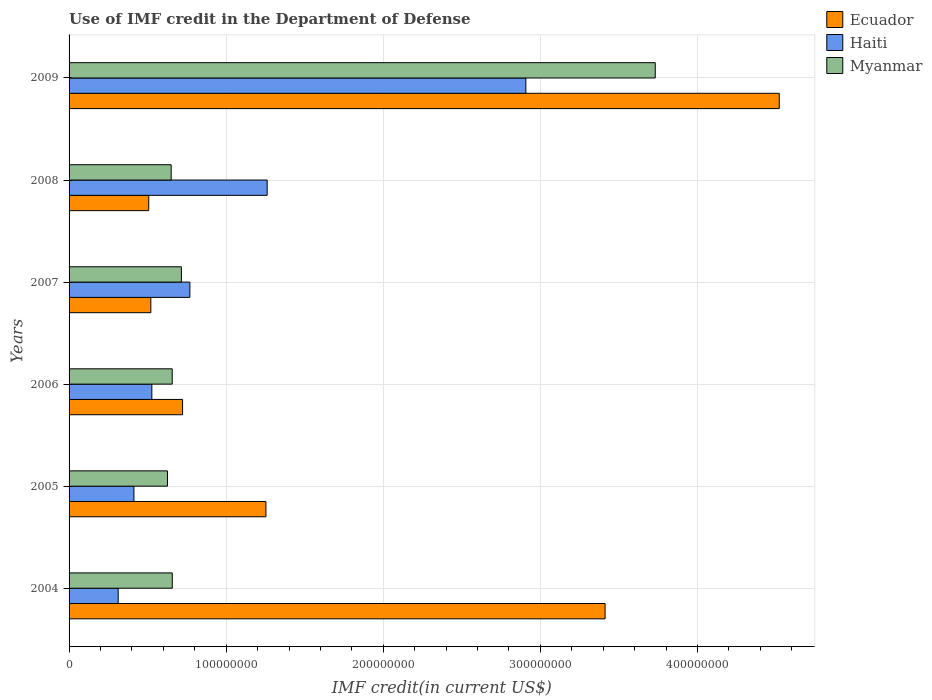How many different coloured bars are there?
Provide a succinct answer. 3. Are the number of bars per tick equal to the number of legend labels?
Offer a terse response. Yes. Are the number of bars on each tick of the Y-axis equal?
Your answer should be very brief. Yes. How many bars are there on the 4th tick from the top?
Your answer should be very brief. 3. How many bars are there on the 5th tick from the bottom?
Provide a succinct answer. 3. What is the IMF credit in the Department of Defense in Myanmar in 2005?
Keep it short and to the point. 6.26e+07. Across all years, what is the maximum IMF credit in the Department of Defense in Ecuador?
Your answer should be compact. 4.52e+08. Across all years, what is the minimum IMF credit in the Department of Defense in Haiti?
Provide a succinct answer. 3.13e+07. In which year was the IMF credit in the Department of Defense in Haiti maximum?
Give a very brief answer. 2009. What is the total IMF credit in the Department of Defense in Ecuador in the graph?
Ensure brevity in your answer.  1.09e+09. What is the difference between the IMF credit in the Department of Defense in Haiti in 2005 and that in 2008?
Offer a terse response. -8.48e+07. What is the difference between the IMF credit in the Department of Defense in Myanmar in 2004 and the IMF credit in the Department of Defense in Haiti in 2005?
Offer a very short reply. 2.44e+07. What is the average IMF credit in the Department of Defense in Ecuador per year?
Your answer should be very brief. 1.82e+08. In the year 2007, what is the difference between the IMF credit in the Department of Defense in Ecuador and IMF credit in the Department of Defense in Myanmar?
Give a very brief answer. -1.95e+07. In how many years, is the IMF credit in the Department of Defense in Myanmar greater than 260000000 US$?
Provide a succinct answer. 1. What is the ratio of the IMF credit in the Department of Defense in Ecuador in 2004 to that in 2007?
Offer a terse response. 6.56. Is the IMF credit in the Department of Defense in Ecuador in 2008 less than that in 2009?
Provide a succinct answer. Yes. Is the difference between the IMF credit in the Department of Defense in Ecuador in 2005 and 2008 greater than the difference between the IMF credit in the Department of Defense in Myanmar in 2005 and 2008?
Provide a succinct answer. Yes. What is the difference between the highest and the second highest IMF credit in the Department of Defense in Myanmar?
Your answer should be very brief. 3.02e+08. What is the difference between the highest and the lowest IMF credit in the Department of Defense in Ecuador?
Offer a terse response. 4.01e+08. What does the 3rd bar from the top in 2004 represents?
Make the answer very short. Ecuador. What does the 1st bar from the bottom in 2006 represents?
Ensure brevity in your answer.  Ecuador. Does the graph contain any zero values?
Offer a very short reply. No. Does the graph contain grids?
Your response must be concise. Yes. Where does the legend appear in the graph?
Offer a very short reply. Top right. How many legend labels are there?
Your answer should be compact. 3. How are the legend labels stacked?
Ensure brevity in your answer.  Vertical. What is the title of the graph?
Provide a short and direct response. Use of IMF credit in the Department of Defense. Does "Algeria" appear as one of the legend labels in the graph?
Keep it short and to the point. No. What is the label or title of the X-axis?
Ensure brevity in your answer.  IMF credit(in current US$). What is the label or title of the Y-axis?
Make the answer very short. Years. What is the IMF credit(in current US$) of Ecuador in 2004?
Give a very brief answer. 3.41e+08. What is the IMF credit(in current US$) in Haiti in 2004?
Provide a short and direct response. 3.13e+07. What is the IMF credit(in current US$) of Myanmar in 2004?
Offer a very short reply. 6.57e+07. What is the IMF credit(in current US$) of Ecuador in 2005?
Offer a very short reply. 1.25e+08. What is the IMF credit(in current US$) in Haiti in 2005?
Keep it short and to the point. 4.13e+07. What is the IMF credit(in current US$) in Myanmar in 2005?
Provide a succinct answer. 6.26e+07. What is the IMF credit(in current US$) in Ecuador in 2006?
Your response must be concise. 7.23e+07. What is the IMF credit(in current US$) in Haiti in 2006?
Your response must be concise. 5.27e+07. What is the IMF credit(in current US$) in Myanmar in 2006?
Your answer should be compact. 6.57e+07. What is the IMF credit(in current US$) of Ecuador in 2007?
Offer a terse response. 5.20e+07. What is the IMF credit(in current US$) in Haiti in 2007?
Offer a very short reply. 7.69e+07. What is the IMF credit(in current US$) in Myanmar in 2007?
Offer a terse response. 7.15e+07. What is the IMF credit(in current US$) in Ecuador in 2008?
Keep it short and to the point. 5.07e+07. What is the IMF credit(in current US$) in Haiti in 2008?
Provide a succinct answer. 1.26e+08. What is the IMF credit(in current US$) of Myanmar in 2008?
Your answer should be compact. 6.50e+07. What is the IMF credit(in current US$) of Ecuador in 2009?
Offer a very short reply. 4.52e+08. What is the IMF credit(in current US$) of Haiti in 2009?
Provide a short and direct response. 2.91e+08. What is the IMF credit(in current US$) of Myanmar in 2009?
Your answer should be very brief. 3.73e+08. Across all years, what is the maximum IMF credit(in current US$) in Ecuador?
Give a very brief answer. 4.52e+08. Across all years, what is the maximum IMF credit(in current US$) of Haiti?
Ensure brevity in your answer.  2.91e+08. Across all years, what is the maximum IMF credit(in current US$) of Myanmar?
Your answer should be compact. 3.73e+08. Across all years, what is the minimum IMF credit(in current US$) of Ecuador?
Ensure brevity in your answer.  5.07e+07. Across all years, what is the minimum IMF credit(in current US$) of Haiti?
Your response must be concise. 3.13e+07. Across all years, what is the minimum IMF credit(in current US$) in Myanmar?
Your response must be concise. 6.26e+07. What is the total IMF credit(in current US$) in Ecuador in the graph?
Provide a succinct answer. 1.09e+09. What is the total IMF credit(in current US$) in Haiti in the graph?
Make the answer very short. 6.19e+08. What is the total IMF credit(in current US$) of Myanmar in the graph?
Provide a short and direct response. 7.04e+08. What is the difference between the IMF credit(in current US$) of Ecuador in 2004 and that in 2005?
Provide a succinct answer. 2.16e+08. What is the difference between the IMF credit(in current US$) in Haiti in 2004 and that in 2005?
Give a very brief answer. -1.00e+07. What is the difference between the IMF credit(in current US$) in Myanmar in 2004 and that in 2005?
Provide a short and direct response. 3.04e+06. What is the difference between the IMF credit(in current US$) of Ecuador in 2004 and that in 2006?
Your answer should be compact. 2.69e+08. What is the difference between the IMF credit(in current US$) of Haiti in 2004 and that in 2006?
Ensure brevity in your answer.  -2.14e+07. What is the difference between the IMF credit(in current US$) of Myanmar in 2004 and that in 2006?
Your answer should be compact. 2.80e+04. What is the difference between the IMF credit(in current US$) in Ecuador in 2004 and that in 2007?
Give a very brief answer. 2.89e+08. What is the difference between the IMF credit(in current US$) of Haiti in 2004 and that in 2007?
Provide a succinct answer. -4.56e+07. What is the difference between the IMF credit(in current US$) of Myanmar in 2004 and that in 2007?
Your answer should be compact. -5.81e+06. What is the difference between the IMF credit(in current US$) of Ecuador in 2004 and that in 2008?
Make the answer very short. 2.90e+08. What is the difference between the IMF credit(in current US$) in Haiti in 2004 and that in 2008?
Your response must be concise. -9.48e+07. What is the difference between the IMF credit(in current US$) in Myanmar in 2004 and that in 2008?
Offer a terse response. 6.85e+05. What is the difference between the IMF credit(in current US$) in Ecuador in 2004 and that in 2009?
Ensure brevity in your answer.  -1.11e+08. What is the difference between the IMF credit(in current US$) of Haiti in 2004 and that in 2009?
Your answer should be compact. -2.59e+08. What is the difference between the IMF credit(in current US$) of Myanmar in 2004 and that in 2009?
Provide a short and direct response. -3.07e+08. What is the difference between the IMF credit(in current US$) of Ecuador in 2005 and that in 2006?
Your answer should be compact. 5.31e+07. What is the difference between the IMF credit(in current US$) in Haiti in 2005 and that in 2006?
Ensure brevity in your answer.  -1.14e+07. What is the difference between the IMF credit(in current US$) in Myanmar in 2005 and that in 2006?
Make the answer very short. -3.01e+06. What is the difference between the IMF credit(in current US$) in Ecuador in 2005 and that in 2007?
Your response must be concise. 7.33e+07. What is the difference between the IMF credit(in current US$) of Haiti in 2005 and that in 2007?
Keep it short and to the point. -3.56e+07. What is the difference between the IMF credit(in current US$) in Myanmar in 2005 and that in 2007?
Keep it short and to the point. -8.85e+06. What is the difference between the IMF credit(in current US$) of Ecuador in 2005 and that in 2008?
Your response must be concise. 7.46e+07. What is the difference between the IMF credit(in current US$) in Haiti in 2005 and that in 2008?
Your answer should be compact. -8.48e+07. What is the difference between the IMF credit(in current US$) of Myanmar in 2005 and that in 2008?
Ensure brevity in your answer.  -2.36e+06. What is the difference between the IMF credit(in current US$) of Ecuador in 2005 and that in 2009?
Give a very brief answer. -3.27e+08. What is the difference between the IMF credit(in current US$) of Haiti in 2005 and that in 2009?
Your response must be concise. -2.49e+08. What is the difference between the IMF credit(in current US$) in Myanmar in 2005 and that in 2009?
Your answer should be very brief. -3.10e+08. What is the difference between the IMF credit(in current US$) in Ecuador in 2006 and that in 2007?
Your answer should be compact. 2.02e+07. What is the difference between the IMF credit(in current US$) in Haiti in 2006 and that in 2007?
Your answer should be very brief. -2.42e+07. What is the difference between the IMF credit(in current US$) in Myanmar in 2006 and that in 2007?
Your answer should be very brief. -5.84e+06. What is the difference between the IMF credit(in current US$) in Ecuador in 2006 and that in 2008?
Your response must be concise. 2.15e+07. What is the difference between the IMF credit(in current US$) of Haiti in 2006 and that in 2008?
Keep it short and to the point. -7.34e+07. What is the difference between the IMF credit(in current US$) of Myanmar in 2006 and that in 2008?
Provide a succinct answer. 6.57e+05. What is the difference between the IMF credit(in current US$) in Ecuador in 2006 and that in 2009?
Offer a terse response. -3.80e+08. What is the difference between the IMF credit(in current US$) of Haiti in 2006 and that in 2009?
Offer a very short reply. -2.38e+08. What is the difference between the IMF credit(in current US$) in Myanmar in 2006 and that in 2009?
Keep it short and to the point. -3.07e+08. What is the difference between the IMF credit(in current US$) of Ecuador in 2007 and that in 2008?
Make the answer very short. 1.32e+06. What is the difference between the IMF credit(in current US$) of Haiti in 2007 and that in 2008?
Your response must be concise. -4.92e+07. What is the difference between the IMF credit(in current US$) of Myanmar in 2007 and that in 2008?
Offer a terse response. 6.50e+06. What is the difference between the IMF credit(in current US$) in Ecuador in 2007 and that in 2009?
Make the answer very short. -4.00e+08. What is the difference between the IMF credit(in current US$) in Haiti in 2007 and that in 2009?
Your answer should be compact. -2.14e+08. What is the difference between the IMF credit(in current US$) in Myanmar in 2007 and that in 2009?
Offer a very short reply. -3.02e+08. What is the difference between the IMF credit(in current US$) in Ecuador in 2008 and that in 2009?
Your answer should be very brief. -4.01e+08. What is the difference between the IMF credit(in current US$) in Haiti in 2008 and that in 2009?
Provide a short and direct response. -1.65e+08. What is the difference between the IMF credit(in current US$) of Myanmar in 2008 and that in 2009?
Provide a short and direct response. -3.08e+08. What is the difference between the IMF credit(in current US$) of Ecuador in 2004 and the IMF credit(in current US$) of Haiti in 2005?
Offer a very short reply. 3.00e+08. What is the difference between the IMF credit(in current US$) in Ecuador in 2004 and the IMF credit(in current US$) in Myanmar in 2005?
Provide a succinct answer. 2.79e+08. What is the difference between the IMF credit(in current US$) in Haiti in 2004 and the IMF credit(in current US$) in Myanmar in 2005?
Offer a very short reply. -3.14e+07. What is the difference between the IMF credit(in current US$) in Ecuador in 2004 and the IMF credit(in current US$) in Haiti in 2006?
Ensure brevity in your answer.  2.88e+08. What is the difference between the IMF credit(in current US$) in Ecuador in 2004 and the IMF credit(in current US$) in Myanmar in 2006?
Make the answer very short. 2.76e+08. What is the difference between the IMF credit(in current US$) of Haiti in 2004 and the IMF credit(in current US$) of Myanmar in 2006?
Give a very brief answer. -3.44e+07. What is the difference between the IMF credit(in current US$) in Ecuador in 2004 and the IMF credit(in current US$) in Haiti in 2007?
Your response must be concise. 2.64e+08. What is the difference between the IMF credit(in current US$) in Ecuador in 2004 and the IMF credit(in current US$) in Myanmar in 2007?
Your answer should be compact. 2.70e+08. What is the difference between the IMF credit(in current US$) of Haiti in 2004 and the IMF credit(in current US$) of Myanmar in 2007?
Provide a short and direct response. -4.02e+07. What is the difference between the IMF credit(in current US$) of Ecuador in 2004 and the IMF credit(in current US$) of Haiti in 2008?
Your answer should be very brief. 2.15e+08. What is the difference between the IMF credit(in current US$) of Ecuador in 2004 and the IMF credit(in current US$) of Myanmar in 2008?
Give a very brief answer. 2.76e+08. What is the difference between the IMF credit(in current US$) of Haiti in 2004 and the IMF credit(in current US$) of Myanmar in 2008?
Provide a short and direct response. -3.37e+07. What is the difference between the IMF credit(in current US$) of Ecuador in 2004 and the IMF credit(in current US$) of Haiti in 2009?
Offer a terse response. 5.04e+07. What is the difference between the IMF credit(in current US$) in Ecuador in 2004 and the IMF credit(in current US$) in Myanmar in 2009?
Ensure brevity in your answer.  -3.19e+07. What is the difference between the IMF credit(in current US$) in Haiti in 2004 and the IMF credit(in current US$) in Myanmar in 2009?
Provide a succinct answer. -3.42e+08. What is the difference between the IMF credit(in current US$) in Ecuador in 2005 and the IMF credit(in current US$) in Haiti in 2006?
Keep it short and to the point. 7.26e+07. What is the difference between the IMF credit(in current US$) in Ecuador in 2005 and the IMF credit(in current US$) in Myanmar in 2006?
Keep it short and to the point. 5.97e+07. What is the difference between the IMF credit(in current US$) of Haiti in 2005 and the IMF credit(in current US$) of Myanmar in 2006?
Your response must be concise. -2.44e+07. What is the difference between the IMF credit(in current US$) in Ecuador in 2005 and the IMF credit(in current US$) in Haiti in 2007?
Give a very brief answer. 4.84e+07. What is the difference between the IMF credit(in current US$) in Ecuador in 2005 and the IMF credit(in current US$) in Myanmar in 2007?
Give a very brief answer. 5.38e+07. What is the difference between the IMF credit(in current US$) of Haiti in 2005 and the IMF credit(in current US$) of Myanmar in 2007?
Your answer should be compact. -3.02e+07. What is the difference between the IMF credit(in current US$) of Ecuador in 2005 and the IMF credit(in current US$) of Haiti in 2008?
Offer a very short reply. -7.85e+05. What is the difference between the IMF credit(in current US$) in Ecuador in 2005 and the IMF credit(in current US$) in Myanmar in 2008?
Ensure brevity in your answer.  6.03e+07. What is the difference between the IMF credit(in current US$) of Haiti in 2005 and the IMF credit(in current US$) of Myanmar in 2008?
Keep it short and to the point. -2.37e+07. What is the difference between the IMF credit(in current US$) in Ecuador in 2005 and the IMF credit(in current US$) in Haiti in 2009?
Give a very brief answer. -1.65e+08. What is the difference between the IMF credit(in current US$) of Ecuador in 2005 and the IMF credit(in current US$) of Myanmar in 2009?
Ensure brevity in your answer.  -2.48e+08. What is the difference between the IMF credit(in current US$) in Haiti in 2005 and the IMF credit(in current US$) in Myanmar in 2009?
Your answer should be compact. -3.32e+08. What is the difference between the IMF credit(in current US$) of Ecuador in 2006 and the IMF credit(in current US$) of Haiti in 2007?
Your response must be concise. -4.64e+06. What is the difference between the IMF credit(in current US$) of Ecuador in 2006 and the IMF credit(in current US$) of Myanmar in 2007?
Your answer should be very brief. 7.61e+05. What is the difference between the IMF credit(in current US$) in Haiti in 2006 and the IMF credit(in current US$) in Myanmar in 2007?
Keep it short and to the point. -1.88e+07. What is the difference between the IMF credit(in current US$) in Ecuador in 2006 and the IMF credit(in current US$) in Haiti in 2008?
Your response must be concise. -5.38e+07. What is the difference between the IMF credit(in current US$) of Ecuador in 2006 and the IMF credit(in current US$) of Myanmar in 2008?
Offer a very short reply. 7.26e+06. What is the difference between the IMF credit(in current US$) of Haiti in 2006 and the IMF credit(in current US$) of Myanmar in 2008?
Give a very brief answer. -1.23e+07. What is the difference between the IMF credit(in current US$) of Ecuador in 2006 and the IMF credit(in current US$) of Haiti in 2009?
Offer a very short reply. -2.18e+08. What is the difference between the IMF credit(in current US$) in Ecuador in 2006 and the IMF credit(in current US$) in Myanmar in 2009?
Provide a short and direct response. -3.01e+08. What is the difference between the IMF credit(in current US$) of Haiti in 2006 and the IMF credit(in current US$) of Myanmar in 2009?
Your answer should be very brief. -3.20e+08. What is the difference between the IMF credit(in current US$) of Ecuador in 2007 and the IMF credit(in current US$) of Haiti in 2008?
Offer a very short reply. -7.41e+07. What is the difference between the IMF credit(in current US$) in Ecuador in 2007 and the IMF credit(in current US$) in Myanmar in 2008?
Your response must be concise. -1.30e+07. What is the difference between the IMF credit(in current US$) in Haiti in 2007 and the IMF credit(in current US$) in Myanmar in 2008?
Make the answer very short. 1.19e+07. What is the difference between the IMF credit(in current US$) in Ecuador in 2007 and the IMF credit(in current US$) in Haiti in 2009?
Keep it short and to the point. -2.39e+08. What is the difference between the IMF credit(in current US$) in Ecuador in 2007 and the IMF credit(in current US$) in Myanmar in 2009?
Your answer should be compact. -3.21e+08. What is the difference between the IMF credit(in current US$) in Haiti in 2007 and the IMF credit(in current US$) in Myanmar in 2009?
Your response must be concise. -2.96e+08. What is the difference between the IMF credit(in current US$) of Ecuador in 2008 and the IMF credit(in current US$) of Haiti in 2009?
Offer a terse response. -2.40e+08. What is the difference between the IMF credit(in current US$) in Ecuador in 2008 and the IMF credit(in current US$) in Myanmar in 2009?
Keep it short and to the point. -3.22e+08. What is the difference between the IMF credit(in current US$) in Haiti in 2008 and the IMF credit(in current US$) in Myanmar in 2009?
Keep it short and to the point. -2.47e+08. What is the average IMF credit(in current US$) of Ecuador per year?
Your response must be concise. 1.82e+08. What is the average IMF credit(in current US$) of Haiti per year?
Make the answer very short. 1.03e+08. What is the average IMF credit(in current US$) of Myanmar per year?
Your answer should be compact. 1.17e+08. In the year 2004, what is the difference between the IMF credit(in current US$) in Ecuador and IMF credit(in current US$) in Haiti?
Offer a very short reply. 3.10e+08. In the year 2004, what is the difference between the IMF credit(in current US$) of Ecuador and IMF credit(in current US$) of Myanmar?
Your response must be concise. 2.76e+08. In the year 2004, what is the difference between the IMF credit(in current US$) of Haiti and IMF credit(in current US$) of Myanmar?
Provide a succinct answer. -3.44e+07. In the year 2005, what is the difference between the IMF credit(in current US$) of Ecuador and IMF credit(in current US$) of Haiti?
Give a very brief answer. 8.40e+07. In the year 2005, what is the difference between the IMF credit(in current US$) in Ecuador and IMF credit(in current US$) in Myanmar?
Provide a succinct answer. 6.27e+07. In the year 2005, what is the difference between the IMF credit(in current US$) in Haiti and IMF credit(in current US$) in Myanmar?
Offer a terse response. -2.14e+07. In the year 2006, what is the difference between the IMF credit(in current US$) in Ecuador and IMF credit(in current US$) in Haiti?
Provide a succinct answer. 1.96e+07. In the year 2006, what is the difference between the IMF credit(in current US$) in Ecuador and IMF credit(in current US$) in Myanmar?
Offer a very short reply. 6.60e+06. In the year 2006, what is the difference between the IMF credit(in current US$) of Haiti and IMF credit(in current US$) of Myanmar?
Offer a terse response. -1.30e+07. In the year 2007, what is the difference between the IMF credit(in current US$) of Ecuador and IMF credit(in current US$) of Haiti?
Give a very brief answer. -2.49e+07. In the year 2007, what is the difference between the IMF credit(in current US$) of Ecuador and IMF credit(in current US$) of Myanmar?
Provide a succinct answer. -1.95e+07. In the year 2007, what is the difference between the IMF credit(in current US$) of Haiti and IMF credit(in current US$) of Myanmar?
Give a very brief answer. 5.40e+06. In the year 2008, what is the difference between the IMF credit(in current US$) in Ecuador and IMF credit(in current US$) in Haiti?
Make the answer very short. -7.54e+07. In the year 2008, what is the difference between the IMF credit(in current US$) in Ecuador and IMF credit(in current US$) in Myanmar?
Provide a short and direct response. -1.43e+07. In the year 2008, what is the difference between the IMF credit(in current US$) of Haiti and IMF credit(in current US$) of Myanmar?
Your answer should be compact. 6.11e+07. In the year 2009, what is the difference between the IMF credit(in current US$) in Ecuador and IMF credit(in current US$) in Haiti?
Offer a terse response. 1.61e+08. In the year 2009, what is the difference between the IMF credit(in current US$) in Ecuador and IMF credit(in current US$) in Myanmar?
Your answer should be compact. 7.89e+07. In the year 2009, what is the difference between the IMF credit(in current US$) in Haiti and IMF credit(in current US$) in Myanmar?
Your answer should be compact. -8.24e+07. What is the ratio of the IMF credit(in current US$) of Ecuador in 2004 to that in 2005?
Your answer should be very brief. 2.72. What is the ratio of the IMF credit(in current US$) of Haiti in 2004 to that in 2005?
Your response must be concise. 0.76. What is the ratio of the IMF credit(in current US$) in Myanmar in 2004 to that in 2005?
Make the answer very short. 1.05. What is the ratio of the IMF credit(in current US$) of Ecuador in 2004 to that in 2006?
Your answer should be very brief. 4.72. What is the ratio of the IMF credit(in current US$) in Haiti in 2004 to that in 2006?
Your response must be concise. 0.59. What is the ratio of the IMF credit(in current US$) of Myanmar in 2004 to that in 2006?
Provide a succinct answer. 1. What is the ratio of the IMF credit(in current US$) of Ecuador in 2004 to that in 2007?
Give a very brief answer. 6.56. What is the ratio of the IMF credit(in current US$) in Haiti in 2004 to that in 2007?
Offer a terse response. 0.41. What is the ratio of the IMF credit(in current US$) of Myanmar in 2004 to that in 2007?
Make the answer very short. 0.92. What is the ratio of the IMF credit(in current US$) in Ecuador in 2004 to that in 2008?
Offer a very short reply. 6.73. What is the ratio of the IMF credit(in current US$) in Haiti in 2004 to that in 2008?
Provide a short and direct response. 0.25. What is the ratio of the IMF credit(in current US$) of Myanmar in 2004 to that in 2008?
Make the answer very short. 1.01. What is the ratio of the IMF credit(in current US$) in Ecuador in 2004 to that in 2009?
Make the answer very short. 0.75. What is the ratio of the IMF credit(in current US$) of Haiti in 2004 to that in 2009?
Provide a short and direct response. 0.11. What is the ratio of the IMF credit(in current US$) in Myanmar in 2004 to that in 2009?
Your answer should be compact. 0.18. What is the ratio of the IMF credit(in current US$) in Ecuador in 2005 to that in 2006?
Your answer should be very brief. 1.73. What is the ratio of the IMF credit(in current US$) in Haiti in 2005 to that in 2006?
Offer a terse response. 0.78. What is the ratio of the IMF credit(in current US$) in Myanmar in 2005 to that in 2006?
Give a very brief answer. 0.95. What is the ratio of the IMF credit(in current US$) of Ecuador in 2005 to that in 2007?
Offer a terse response. 2.41. What is the ratio of the IMF credit(in current US$) of Haiti in 2005 to that in 2007?
Keep it short and to the point. 0.54. What is the ratio of the IMF credit(in current US$) of Myanmar in 2005 to that in 2007?
Give a very brief answer. 0.88. What is the ratio of the IMF credit(in current US$) in Ecuador in 2005 to that in 2008?
Provide a succinct answer. 2.47. What is the ratio of the IMF credit(in current US$) of Haiti in 2005 to that in 2008?
Make the answer very short. 0.33. What is the ratio of the IMF credit(in current US$) in Myanmar in 2005 to that in 2008?
Offer a very short reply. 0.96. What is the ratio of the IMF credit(in current US$) in Ecuador in 2005 to that in 2009?
Give a very brief answer. 0.28. What is the ratio of the IMF credit(in current US$) in Haiti in 2005 to that in 2009?
Ensure brevity in your answer.  0.14. What is the ratio of the IMF credit(in current US$) in Myanmar in 2005 to that in 2009?
Give a very brief answer. 0.17. What is the ratio of the IMF credit(in current US$) in Ecuador in 2006 to that in 2007?
Your answer should be very brief. 1.39. What is the ratio of the IMF credit(in current US$) in Haiti in 2006 to that in 2007?
Offer a terse response. 0.69. What is the ratio of the IMF credit(in current US$) of Myanmar in 2006 to that in 2007?
Provide a succinct answer. 0.92. What is the ratio of the IMF credit(in current US$) in Ecuador in 2006 to that in 2008?
Your answer should be very brief. 1.42. What is the ratio of the IMF credit(in current US$) of Haiti in 2006 to that in 2008?
Keep it short and to the point. 0.42. What is the ratio of the IMF credit(in current US$) of Myanmar in 2006 to that in 2008?
Your answer should be compact. 1.01. What is the ratio of the IMF credit(in current US$) of Ecuador in 2006 to that in 2009?
Your response must be concise. 0.16. What is the ratio of the IMF credit(in current US$) in Haiti in 2006 to that in 2009?
Your answer should be very brief. 0.18. What is the ratio of the IMF credit(in current US$) of Myanmar in 2006 to that in 2009?
Offer a very short reply. 0.18. What is the ratio of the IMF credit(in current US$) in Ecuador in 2007 to that in 2008?
Ensure brevity in your answer.  1.03. What is the ratio of the IMF credit(in current US$) in Haiti in 2007 to that in 2008?
Ensure brevity in your answer.  0.61. What is the ratio of the IMF credit(in current US$) of Myanmar in 2007 to that in 2008?
Provide a short and direct response. 1.1. What is the ratio of the IMF credit(in current US$) in Ecuador in 2007 to that in 2009?
Make the answer very short. 0.12. What is the ratio of the IMF credit(in current US$) in Haiti in 2007 to that in 2009?
Provide a succinct answer. 0.26. What is the ratio of the IMF credit(in current US$) of Myanmar in 2007 to that in 2009?
Ensure brevity in your answer.  0.19. What is the ratio of the IMF credit(in current US$) in Ecuador in 2008 to that in 2009?
Your response must be concise. 0.11. What is the ratio of the IMF credit(in current US$) of Haiti in 2008 to that in 2009?
Offer a very short reply. 0.43. What is the ratio of the IMF credit(in current US$) in Myanmar in 2008 to that in 2009?
Your response must be concise. 0.17. What is the difference between the highest and the second highest IMF credit(in current US$) in Ecuador?
Your answer should be compact. 1.11e+08. What is the difference between the highest and the second highest IMF credit(in current US$) of Haiti?
Your response must be concise. 1.65e+08. What is the difference between the highest and the second highest IMF credit(in current US$) in Myanmar?
Offer a terse response. 3.02e+08. What is the difference between the highest and the lowest IMF credit(in current US$) of Ecuador?
Offer a very short reply. 4.01e+08. What is the difference between the highest and the lowest IMF credit(in current US$) of Haiti?
Make the answer very short. 2.59e+08. What is the difference between the highest and the lowest IMF credit(in current US$) in Myanmar?
Offer a terse response. 3.10e+08. 